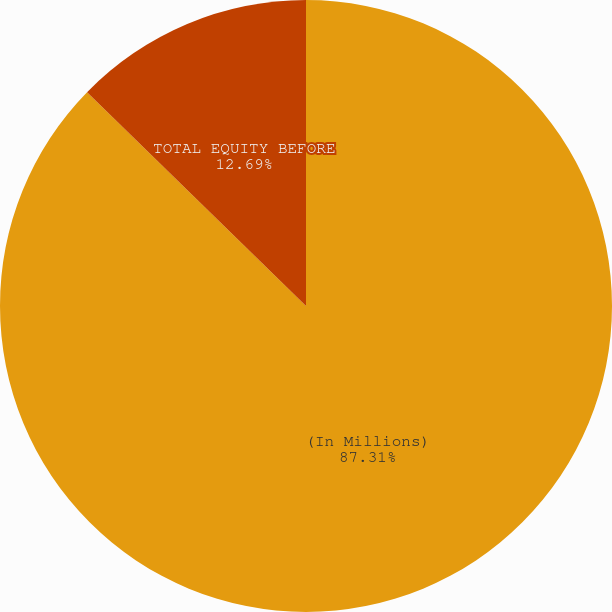Convert chart to OTSL. <chart><loc_0><loc_0><loc_500><loc_500><pie_chart><fcel>(In Millions)<fcel>TOTAL EQUITY BEFORE<nl><fcel>87.31%<fcel>12.69%<nl></chart> 